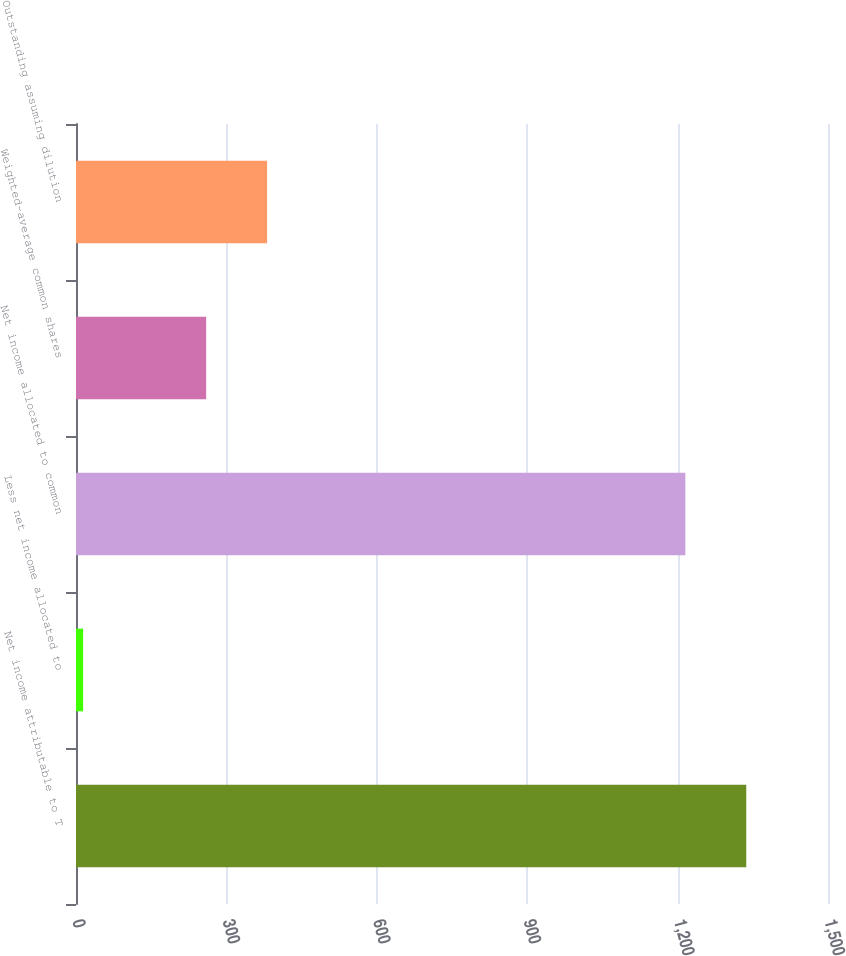Convert chart. <chart><loc_0><loc_0><loc_500><loc_500><bar_chart><fcel>Net income attributable to T<fcel>Less net income allocated to<fcel>Net income allocated to common<fcel>Weighted-average common shares<fcel>Outstanding assuming dilution<nl><fcel>1336.94<fcel>14.2<fcel>1215.4<fcel>259.6<fcel>381.14<nl></chart> 